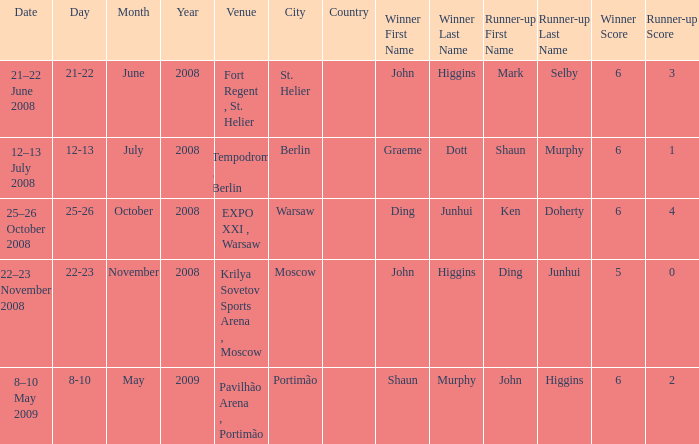Who was the winner in the match that had John Higgins as runner-up? Shaun Murphy. 